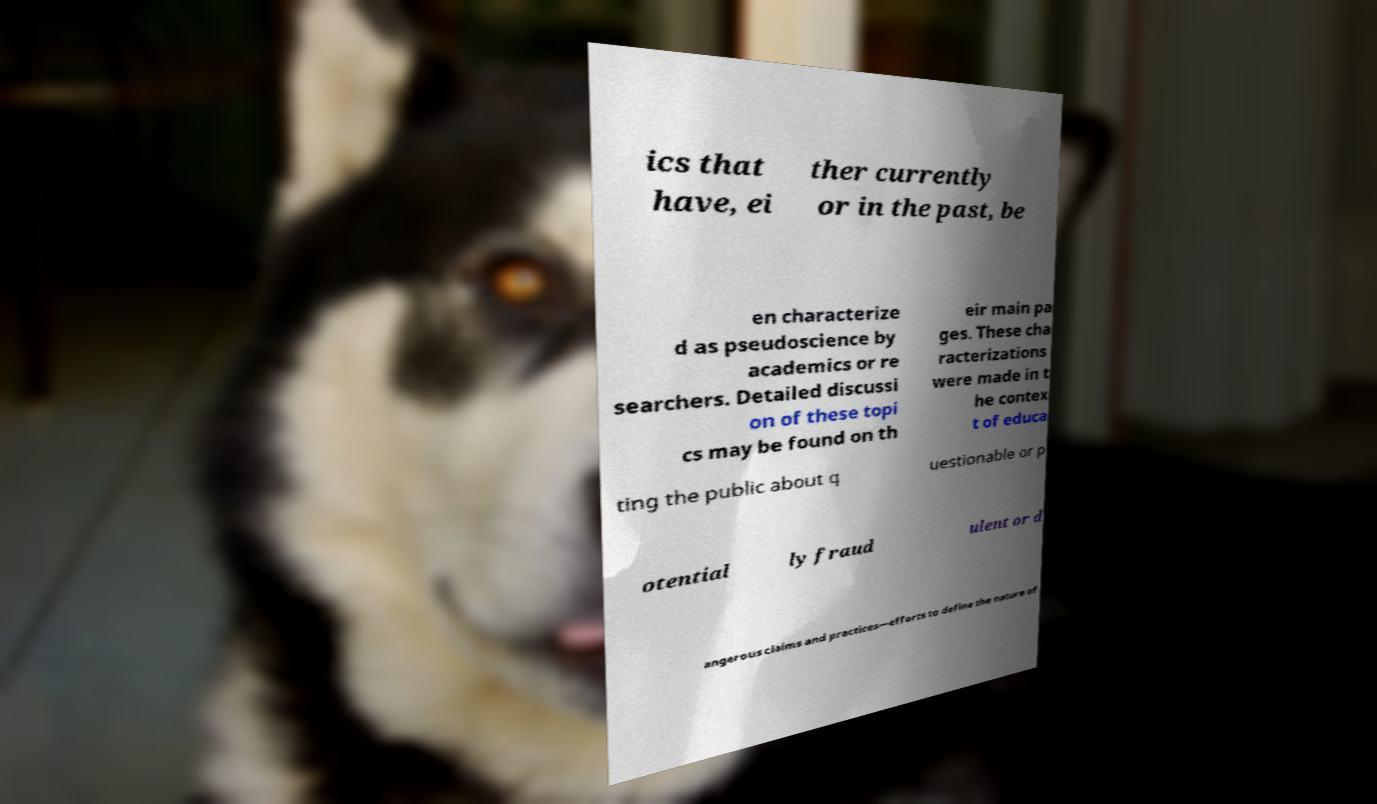Could you extract and type out the text from this image? ics that have, ei ther currently or in the past, be en characterize d as pseudoscience by academics or re searchers. Detailed discussi on of these topi cs may be found on th eir main pa ges. These cha racterizations were made in t he contex t of educa ting the public about q uestionable or p otential ly fraud ulent or d angerous claims and practices—efforts to define the nature of 